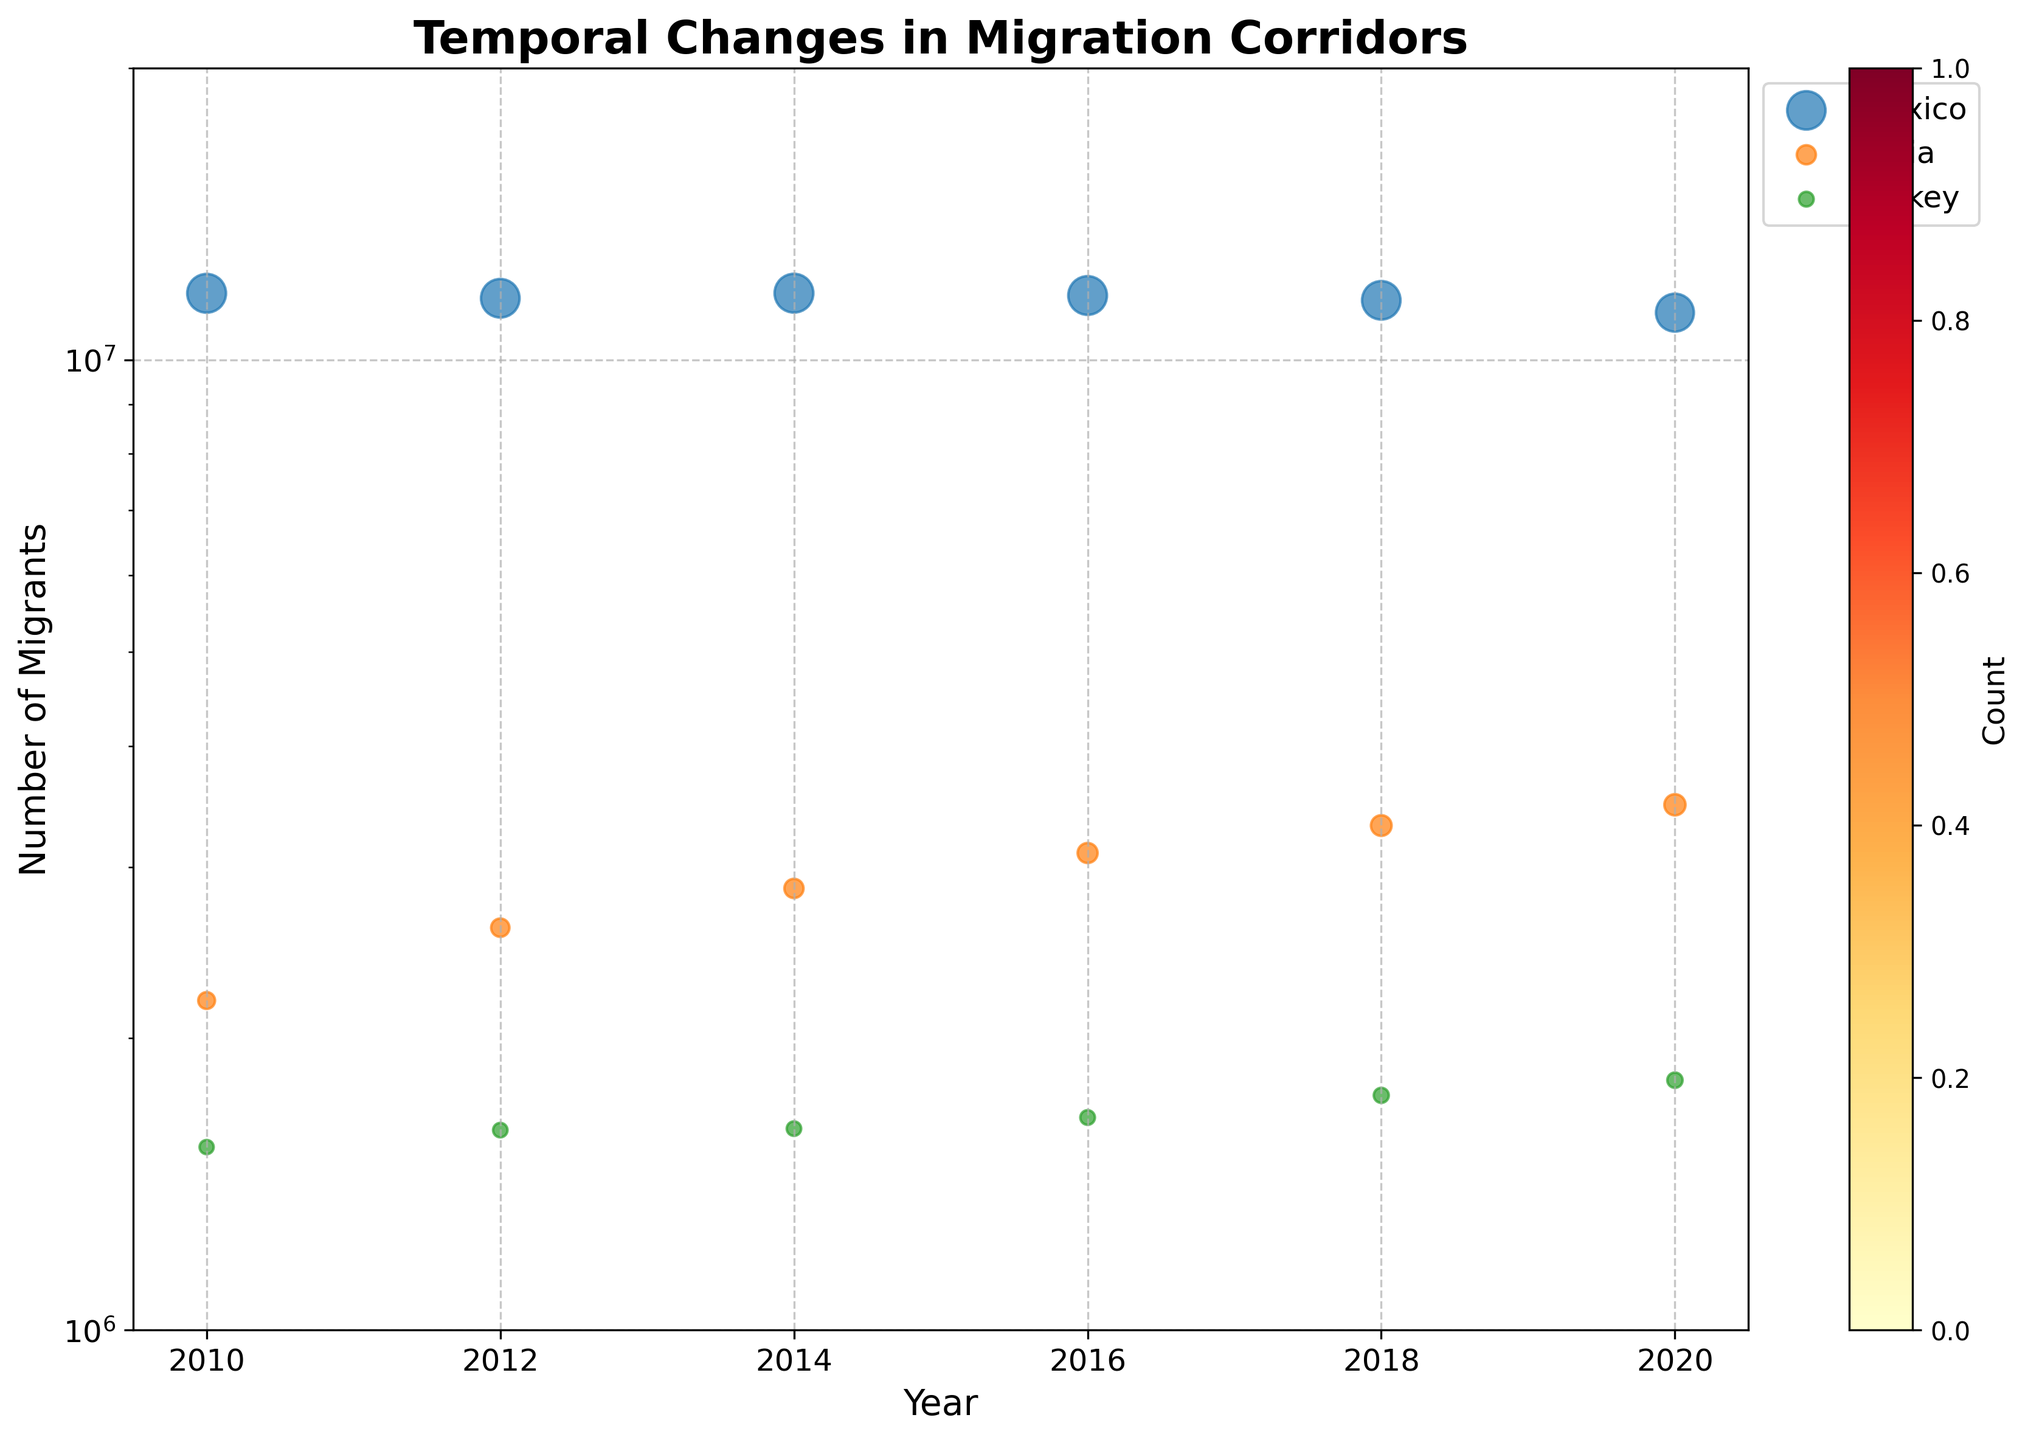What is the title of the plot? The title is usually placed at the top of the figure. Look at the large, bold text right above the plot for this information.
Answer: Temporal Changes in Migration Corridors What does the x-axis represent in the plot? The x-axis label provides this information. Check the label at the bottom of the plot for clarification.
Answer: Year What does the y-axis represent in the plot? The y-axis label provides this information. Look to the left side of the plot for this information.
Answer: Number of Migrants Which origin country has the largest number of migrants to the United States in 2010? To find this, look for the scatter points labeled as "Mexico" and check the size of the points in 2010. The size of the scatter points represents the number of migrants.
Answer: Mexico How has the number of migrants from India to the United Arab Emirates changed from 2010 to 2020? Refer to the scatter points for "India" and observe the sizes from 2010 to 2020. The sizes of the points indicate the number of migrants over the years.
Answer: The number of migrants increased During which year did Turkey have the highest number of migrants to Germany? Look for the scatter points representing "Turkey" and find the one with the largest size. The hexbin plot will also help confirm clustering around these points.
Answer: 2020 Compare the migrant levels from Mexico to the United States and India to the United Arab Emirates in 2018. Which was higher? Check the scatter points for the two origins in 2018. Compare the sizes of the points to determine which origin had more migrants.
Answer: India to the United Arab Emirates Are there any discernible patterns in migration from Turkey to Germany based on the hexbin plot? The hexbin plot shows areas with a higher density of data points. Investigate the hexbin color around the points labeled for Turkey and identify any visible patterns.
Answer: Yes, migration seems to be steadily increasing How do the log scale and grid help in visualizing the data? The log scale allows for a broader range of migrant numbers to be represented more clearly, while the grid makes it easier to compare values. Notice how data points that cover different orders of magnitude are visualized.
Answer: It helps by providing clear visualization despite the large range in values What does the colorbar represent in the hexbin plot? The colorbar is usually placed alongside the plot and indicates the count of data points within each hexbin cell. Observe the label next to the colorbar for details.
Answer: Count 